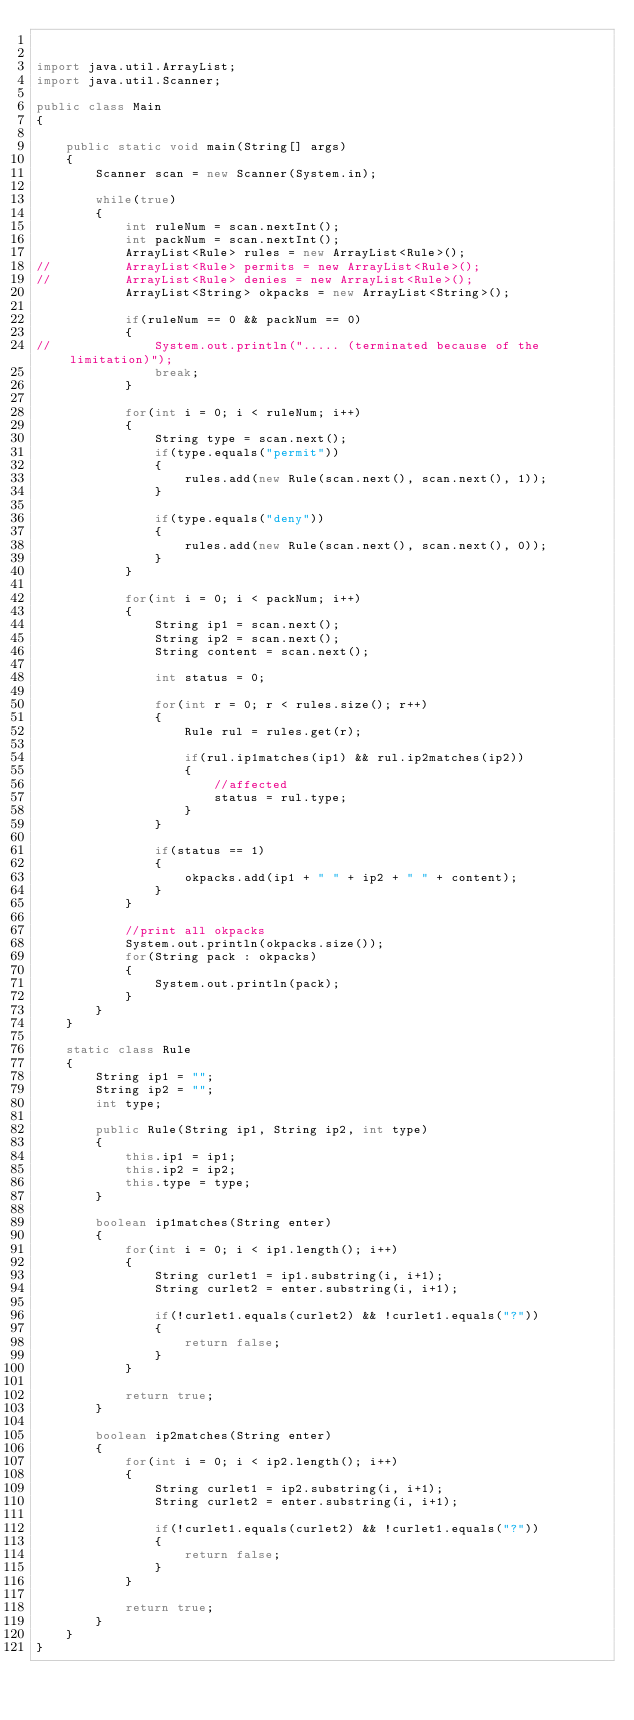Convert code to text. <code><loc_0><loc_0><loc_500><loc_500><_Java_>

import java.util.ArrayList;
import java.util.Scanner;

public class Main 
{

	public static void main(String[] args) 
	{
		Scanner scan = new Scanner(System.in);
		
		while(true)
		{
			int ruleNum = scan.nextInt();
			int packNum = scan.nextInt();
			ArrayList<Rule> rules = new ArrayList<Rule>();
//			ArrayList<Rule> permits = new ArrayList<Rule>();
//			ArrayList<Rule> denies = new ArrayList<Rule>();
			ArrayList<String> okpacks = new ArrayList<String>();
			
			if(ruleNum == 0 && packNum == 0)
			{
//				System.out.println("..... (terminated because of the limitation)");
				break;
			}
			
			for(int i = 0; i < ruleNum; i++)
			{
				String type = scan.next();
				if(type.equals("permit"))
				{
					rules.add(new Rule(scan.next(), scan.next(), 1));
				}
				
				if(type.equals("deny"))
				{
					rules.add(new Rule(scan.next(), scan.next(), 0));
				}
			}
			
			for(int i = 0; i < packNum; i++)
			{
				String ip1 = scan.next();
				String ip2 = scan.next();
				String content = scan.next();
				
				int status = 0;
				
				for(int r = 0; r < rules.size(); r++)
				{
					Rule rul = rules.get(r);
					
					if(rul.ip1matches(ip1) && rul.ip2matches(ip2))
					{
						//affected
						status = rul.type;
					}
				}
				
				if(status == 1)
				{
					okpacks.add(ip1 + " " + ip2 + " " + content);
				}
			}
			
			//print all okpacks
			System.out.println(okpacks.size());
			for(String pack : okpacks)
			{
				System.out.println(pack);
			}
		}
	}
	
	static class Rule
	{
		String ip1 = "";
		String ip2 = "";
		int type;
		
		public Rule(String ip1, String ip2, int type)
		{
			this.ip1 = ip1;
			this.ip2 = ip2;
			this.type = type;
		}
		
		boolean ip1matches(String enter)
		{
			for(int i = 0; i < ip1.length(); i++)
			{
				String curlet1 = ip1.substring(i, i+1);
				String curlet2 = enter.substring(i, i+1);
				
				if(!curlet1.equals(curlet2) && !curlet1.equals("?"))
				{
					return false;
				}
			}
			
			return true;
		}
		
		boolean ip2matches(String enter)
		{
			for(int i = 0; i < ip2.length(); i++)
			{
				String curlet1 = ip2.substring(i, i+1);
				String curlet2 = enter.substring(i, i+1);
				
				if(!curlet1.equals(curlet2) && !curlet1.equals("?"))
				{
					return false;
				}
			}
			
			return true;
		}
	}
}

</code> 